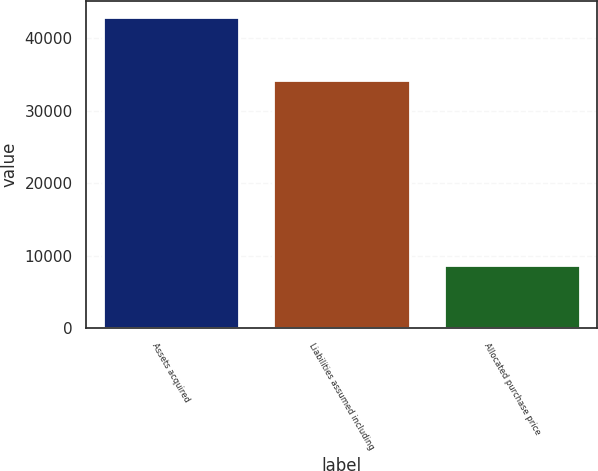<chart> <loc_0><loc_0><loc_500><loc_500><bar_chart><fcel>Assets acquired<fcel>Liabilities assumed including<fcel>Allocated purchase price<nl><fcel>42989<fcel>34233<fcel>8756<nl></chart> 